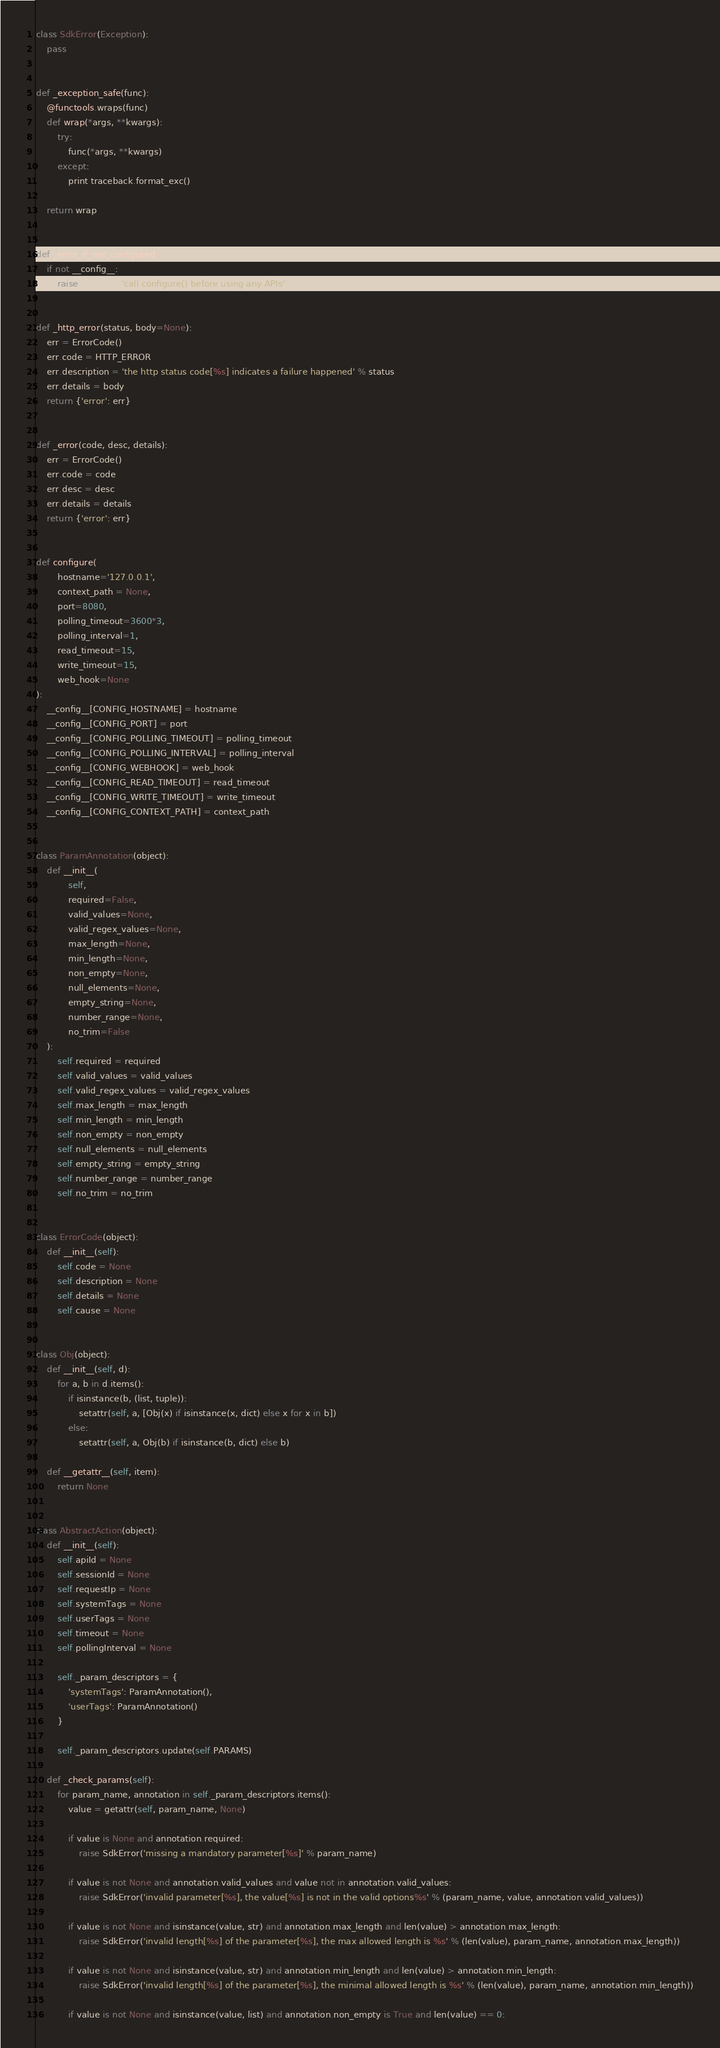Convert code to text. <code><loc_0><loc_0><loc_500><loc_500><_Python_>

class SdkError(Exception):
    pass


def _exception_safe(func):
    @functools.wraps(func)
    def wrap(*args, **kwargs):
        try:
            func(*args, **kwargs)
        except:
            print traceback.format_exc()

    return wrap


def _error_if_not_configured():
    if not __config__:
        raise SdkError('call configure() before using any APIs')


def _http_error(status, body=None):
    err = ErrorCode()
    err.code = HTTP_ERROR
    err.description = 'the http status code[%s] indicates a failure happened' % status
    err.details = body
    return {'error': err}


def _error(code, desc, details):
    err = ErrorCode()
    err.code = code
    err.desc = desc
    err.details = details
    return {'error': err}


def configure(
        hostname='127.0.0.1',
        context_path = None,
        port=8080,
        polling_timeout=3600*3,
        polling_interval=1,
        read_timeout=15,
        write_timeout=15,
        web_hook=None
):
    __config__[CONFIG_HOSTNAME] = hostname
    __config__[CONFIG_PORT] = port
    __config__[CONFIG_POLLING_TIMEOUT] = polling_timeout
    __config__[CONFIG_POLLING_INTERVAL] = polling_interval
    __config__[CONFIG_WEBHOOK] = web_hook
    __config__[CONFIG_READ_TIMEOUT] = read_timeout
    __config__[CONFIG_WRITE_TIMEOUT] = write_timeout
    __config__[CONFIG_CONTEXT_PATH] = context_path


class ParamAnnotation(object):
    def __init__(
            self,
            required=False,
            valid_values=None,
            valid_regex_values=None,
            max_length=None,
            min_length=None,
            non_empty=None,
            null_elements=None,
            empty_string=None,
            number_range=None,
            no_trim=False
    ):
        self.required = required
        self.valid_values = valid_values
        self.valid_regex_values = valid_regex_values
        self.max_length = max_length
        self.min_length = min_length
        self.non_empty = non_empty
        self.null_elements = null_elements
        self.empty_string = empty_string
        self.number_range = number_range
        self.no_trim = no_trim


class ErrorCode(object):
    def __init__(self):
        self.code = None
        self.description = None
        self.details = None
        self.cause = None


class Obj(object):
    def __init__(self, d):
        for a, b in d.items():
            if isinstance(b, (list, tuple)):
                setattr(self, a, [Obj(x) if isinstance(x, dict) else x for x in b])
            else:
                setattr(self, a, Obj(b) if isinstance(b, dict) else b)

    def __getattr__(self, item):
        return None


class AbstractAction(object):
    def __init__(self):
        self.apiId = None
        self.sessionId = None
        self.requestIp = None
        self.systemTags = None
        self.userTags = None
        self.timeout = None
        self.pollingInterval = None

        self._param_descriptors = {
            'systemTags': ParamAnnotation(),
            'userTags': ParamAnnotation()
        }

        self._param_descriptors.update(self.PARAMS)

    def _check_params(self):
        for param_name, annotation in self._param_descriptors.items():
            value = getattr(self, param_name, None)

            if value is None and annotation.required:
                raise SdkError('missing a mandatory parameter[%s]' % param_name)

            if value is not None and annotation.valid_values and value not in annotation.valid_values:
                raise SdkError('invalid parameter[%s], the value[%s] is not in the valid options%s' % (param_name, value, annotation.valid_values))

            if value is not None and isinstance(value, str) and annotation.max_length and len(value) > annotation.max_length:
                raise SdkError('invalid length[%s] of the parameter[%s], the max allowed length is %s' % (len(value), param_name, annotation.max_length))

            if value is not None and isinstance(value, str) and annotation.min_length and len(value) > annotation.min_length:
                raise SdkError('invalid length[%s] of the parameter[%s], the minimal allowed length is %s' % (len(value), param_name, annotation.min_length))

            if value is not None and isinstance(value, list) and annotation.non_empty is True and len(value) == 0:</code> 